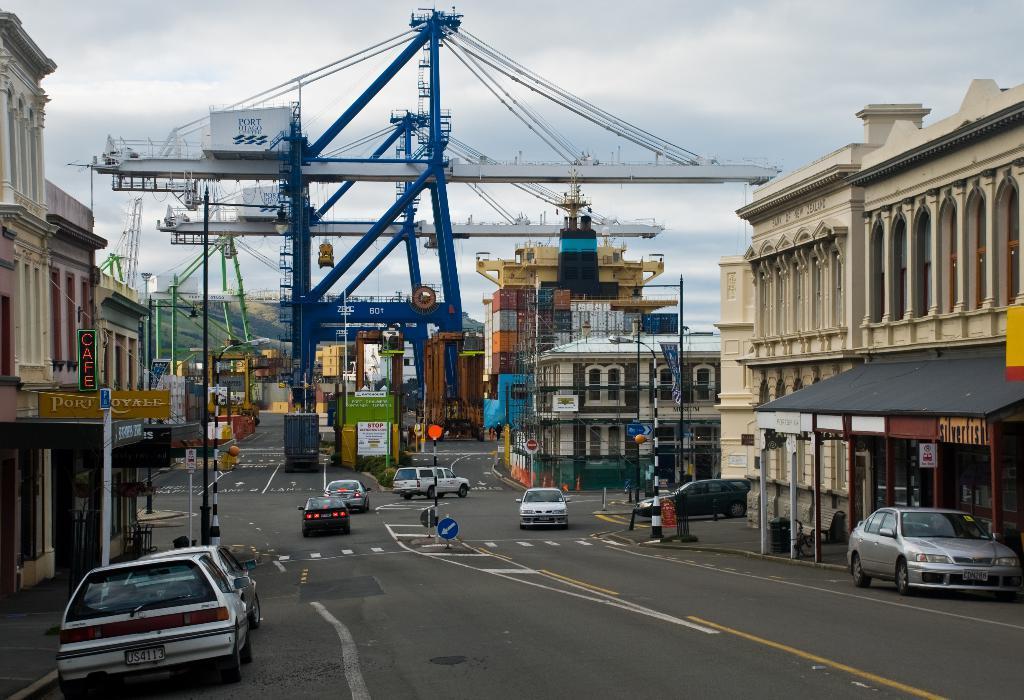Can you describe this image briefly? To the bottom of the image there is a road with few cars. To the left side of the image there is a car on the road. Behind the car there is a footpath and a building with pillars, walls and poles. And to the right side of the image there is a building with pillars and also there is a store with roofs and poles. In front of the store there is a car on the road. And in the background there are blue and white cranes and also there is a construction of building. And to the top of the image there is a sky. 